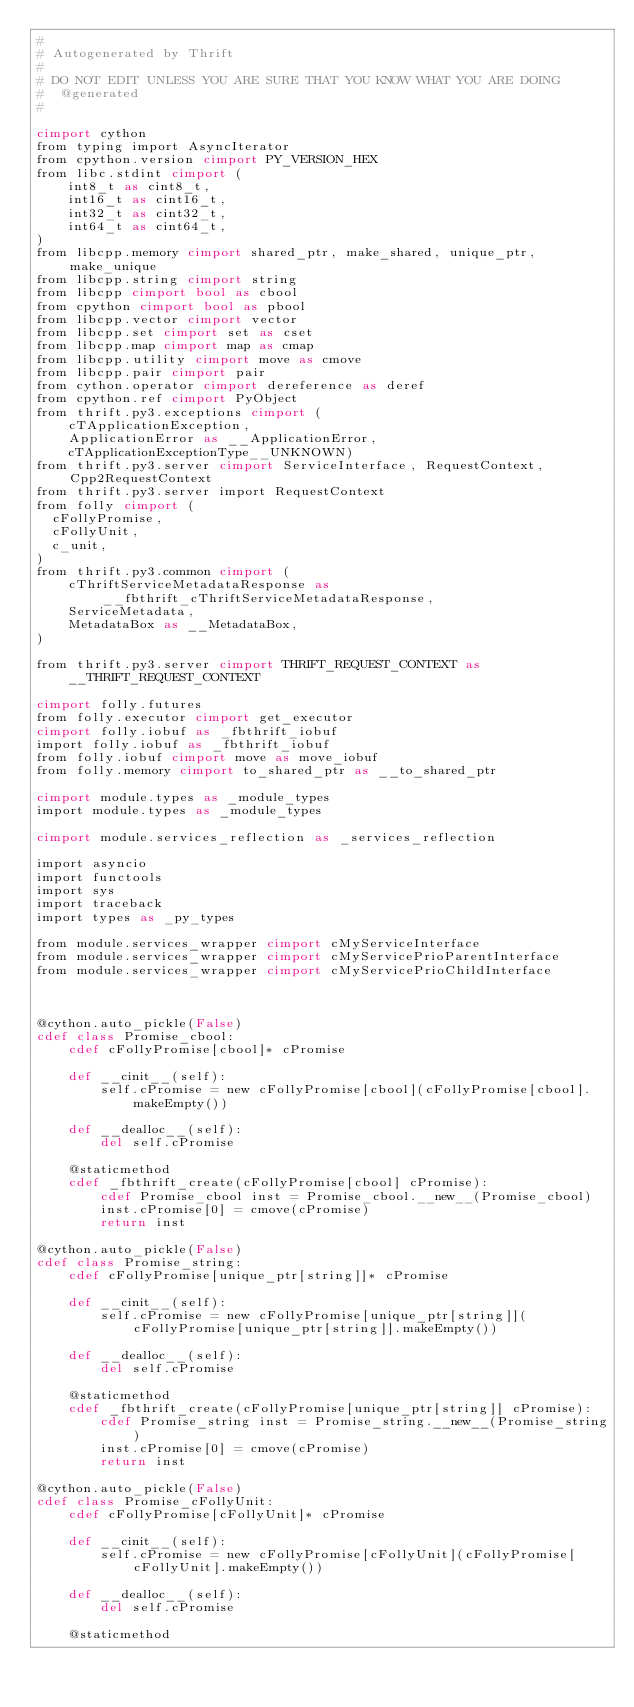<code> <loc_0><loc_0><loc_500><loc_500><_Cython_>#
# Autogenerated by Thrift
#
# DO NOT EDIT UNLESS YOU ARE SURE THAT YOU KNOW WHAT YOU ARE DOING
#  @generated
#

cimport cython
from typing import AsyncIterator
from cpython.version cimport PY_VERSION_HEX
from libc.stdint cimport (
    int8_t as cint8_t,
    int16_t as cint16_t,
    int32_t as cint32_t,
    int64_t as cint64_t,
)
from libcpp.memory cimport shared_ptr, make_shared, unique_ptr, make_unique
from libcpp.string cimport string
from libcpp cimport bool as cbool
from cpython cimport bool as pbool
from libcpp.vector cimport vector
from libcpp.set cimport set as cset
from libcpp.map cimport map as cmap
from libcpp.utility cimport move as cmove
from libcpp.pair cimport pair
from cython.operator cimport dereference as deref
from cpython.ref cimport PyObject
from thrift.py3.exceptions cimport (
    cTApplicationException,
    ApplicationError as __ApplicationError,
    cTApplicationExceptionType__UNKNOWN)
from thrift.py3.server cimport ServiceInterface, RequestContext, Cpp2RequestContext
from thrift.py3.server import RequestContext
from folly cimport (
  cFollyPromise,
  cFollyUnit,
  c_unit,
)
from thrift.py3.common cimport (
    cThriftServiceMetadataResponse as __fbthrift_cThriftServiceMetadataResponse,
    ServiceMetadata,
    MetadataBox as __MetadataBox,
)

from thrift.py3.server cimport THRIFT_REQUEST_CONTEXT as __THRIFT_REQUEST_CONTEXT

cimport folly.futures
from folly.executor cimport get_executor
cimport folly.iobuf as _fbthrift_iobuf
import folly.iobuf as _fbthrift_iobuf
from folly.iobuf cimport move as move_iobuf
from folly.memory cimport to_shared_ptr as __to_shared_ptr

cimport module.types as _module_types
import module.types as _module_types

cimport module.services_reflection as _services_reflection

import asyncio
import functools
import sys
import traceback
import types as _py_types

from module.services_wrapper cimport cMyServiceInterface
from module.services_wrapper cimport cMyServicePrioParentInterface
from module.services_wrapper cimport cMyServicePrioChildInterface



@cython.auto_pickle(False)
cdef class Promise_cbool:
    cdef cFollyPromise[cbool]* cPromise

    def __cinit__(self):
        self.cPromise = new cFollyPromise[cbool](cFollyPromise[cbool].makeEmpty())

    def __dealloc__(self):
        del self.cPromise

    @staticmethod
    cdef _fbthrift_create(cFollyPromise[cbool] cPromise):
        cdef Promise_cbool inst = Promise_cbool.__new__(Promise_cbool)
        inst.cPromise[0] = cmove(cPromise)
        return inst

@cython.auto_pickle(False)
cdef class Promise_string:
    cdef cFollyPromise[unique_ptr[string]]* cPromise

    def __cinit__(self):
        self.cPromise = new cFollyPromise[unique_ptr[string]](cFollyPromise[unique_ptr[string]].makeEmpty())

    def __dealloc__(self):
        del self.cPromise

    @staticmethod
    cdef _fbthrift_create(cFollyPromise[unique_ptr[string]] cPromise):
        cdef Promise_string inst = Promise_string.__new__(Promise_string)
        inst.cPromise[0] = cmove(cPromise)
        return inst

@cython.auto_pickle(False)
cdef class Promise_cFollyUnit:
    cdef cFollyPromise[cFollyUnit]* cPromise

    def __cinit__(self):
        self.cPromise = new cFollyPromise[cFollyUnit](cFollyPromise[cFollyUnit].makeEmpty())

    def __dealloc__(self):
        del self.cPromise

    @staticmethod</code> 